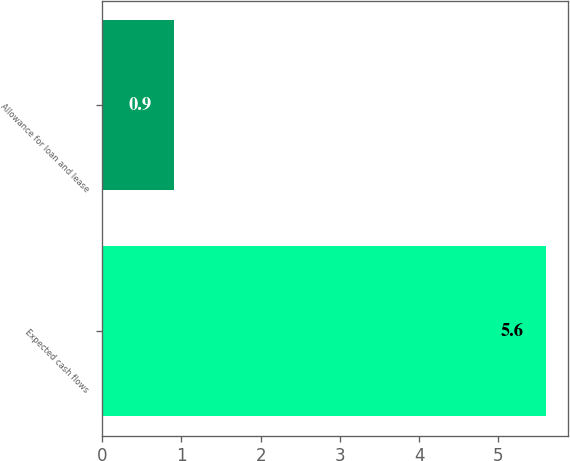<chart> <loc_0><loc_0><loc_500><loc_500><bar_chart><fcel>Expected cash flows<fcel>Allowance for loan and lease<nl><fcel>5.6<fcel>0.9<nl></chart> 